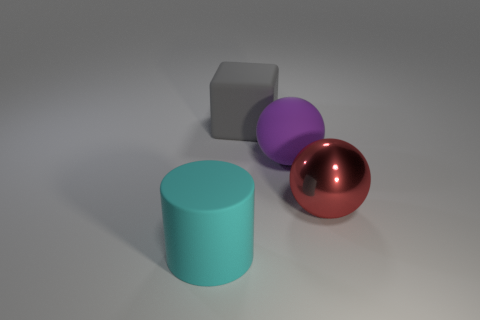Is the number of large matte things to the right of the red metallic sphere the same as the number of large red things?
Ensure brevity in your answer.  No. How many other objects are the same material as the large gray thing?
Your answer should be very brief. 2. Do the rubber thing in front of the large purple matte ball and the sphere that is in front of the big rubber ball have the same size?
Your answer should be compact. Yes. How many things are either things behind the big cyan matte cylinder or things to the right of the big rubber ball?
Offer a terse response. 3. Is there any other thing that is the same shape as the red metallic thing?
Keep it short and to the point. Yes. There is a object that is in front of the large red object; is its color the same as the large sphere that is behind the large metal sphere?
Offer a terse response. No. How many matte things are either big cylinders or large red blocks?
Offer a terse response. 1. Are there any other things that have the same size as the red metal thing?
Your answer should be very brief. Yes. There is a matte thing behind the purple rubber sphere in front of the big gray matte object; what is its shape?
Offer a very short reply. Cube. Is the thing on the right side of the purple matte thing made of the same material as the object in front of the red shiny ball?
Your answer should be compact. No. 